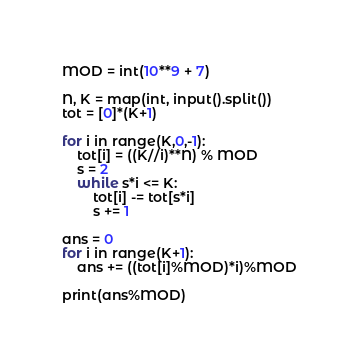Convert code to text. <code><loc_0><loc_0><loc_500><loc_500><_Python_>MOD = int(10**9 + 7)

N, K = map(int, input().split())
tot = [0]*(K+1)

for i in range(K,0,-1):
    tot[i] = ((K//i)**N) % MOD
    s = 2
    while s*i <= K:
        tot[i] -= tot[s*i]
        s += 1
        
ans = 0
for i in range(K+1):
    ans += ((tot[i]%MOD)*i)%MOD

print(ans%MOD)</code> 